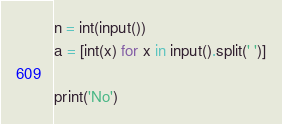<code> <loc_0><loc_0><loc_500><loc_500><_Python_>n = int(input())
a = [int(x) for x in input().split(' ')]

print('No')</code> 